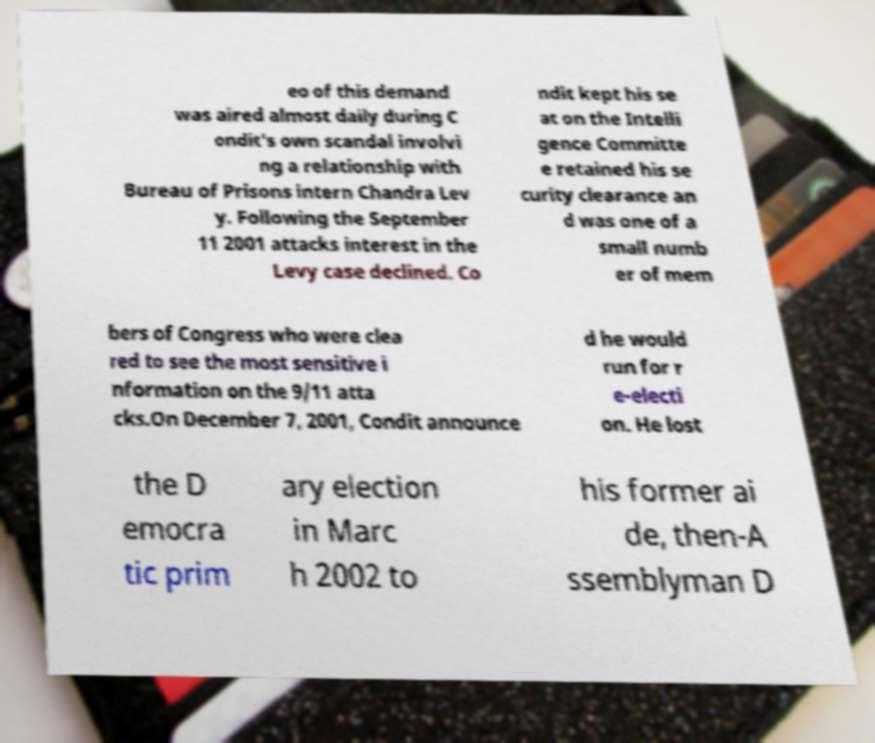Can you accurately transcribe the text from the provided image for me? eo of this demand was aired almost daily during C ondit's own scandal involvi ng a relationship with Bureau of Prisons intern Chandra Lev y. Following the September 11 2001 attacks interest in the Levy case declined. Co ndit kept his se at on the Intelli gence Committe e retained his se curity clearance an d was one of a small numb er of mem bers of Congress who were clea red to see the most sensitive i nformation on the 9/11 atta cks.On December 7, 2001, Condit announce d he would run for r e-electi on. He lost the D emocra tic prim ary election in Marc h 2002 to his former ai de, then-A ssemblyman D 